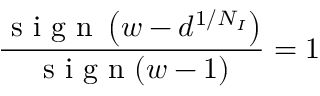<formula> <loc_0><loc_0><loc_500><loc_500>\frac { s i g n \left ( w - d ^ { 1 / N _ { I } } \right ) } { s i g n ( w - 1 ) } = 1</formula> 